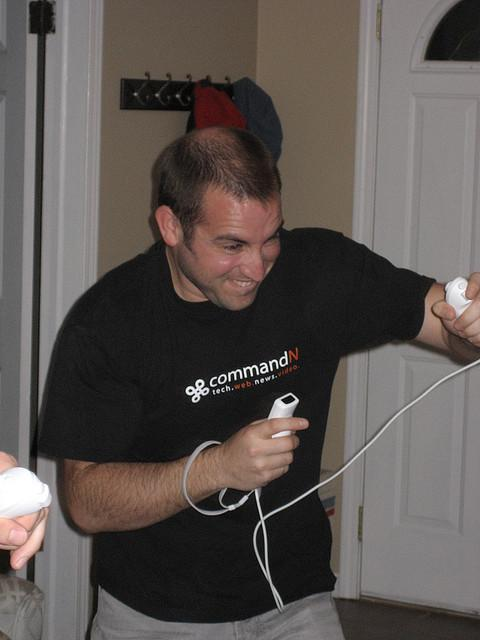What is wrapped around his wrist? wrist strap 